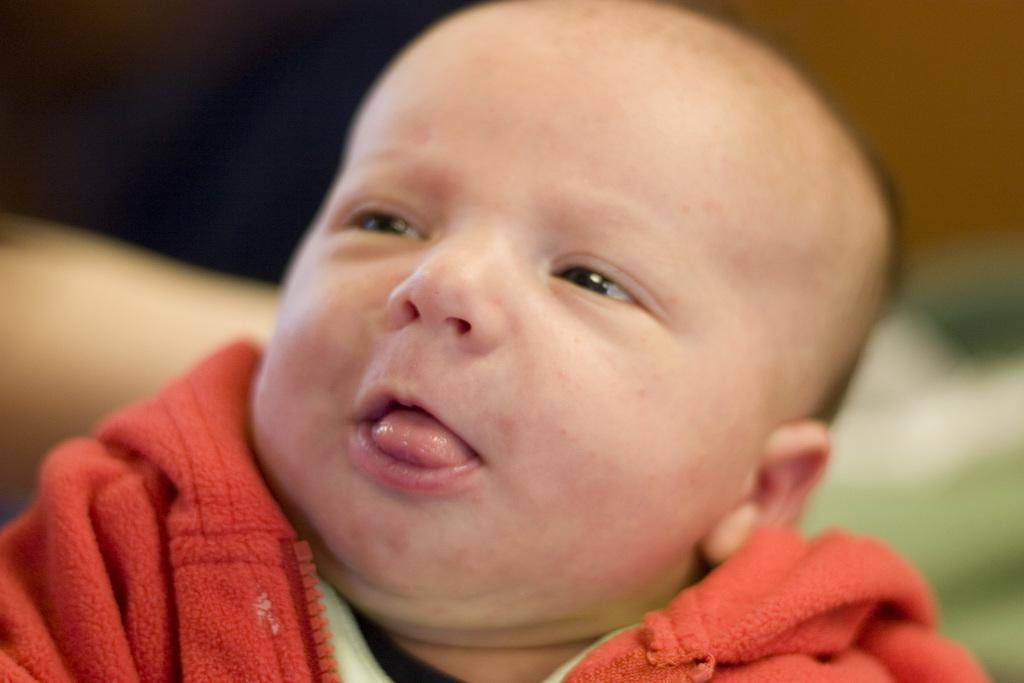How would you summarize this image in a sentence or two? As we can see in the image in the front there is a child wearing red color jacket and the background is blurred. 